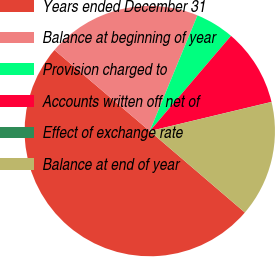Convert chart to OTSL. <chart><loc_0><loc_0><loc_500><loc_500><pie_chart><fcel>Years ended December 31<fcel>Balance at beginning of year<fcel>Provision charged to<fcel>Accounts written off net of<fcel>Effect of exchange rate<fcel>Balance at end of year<nl><fcel>49.95%<fcel>20.0%<fcel>5.02%<fcel>10.01%<fcel>0.02%<fcel>15.0%<nl></chart> 